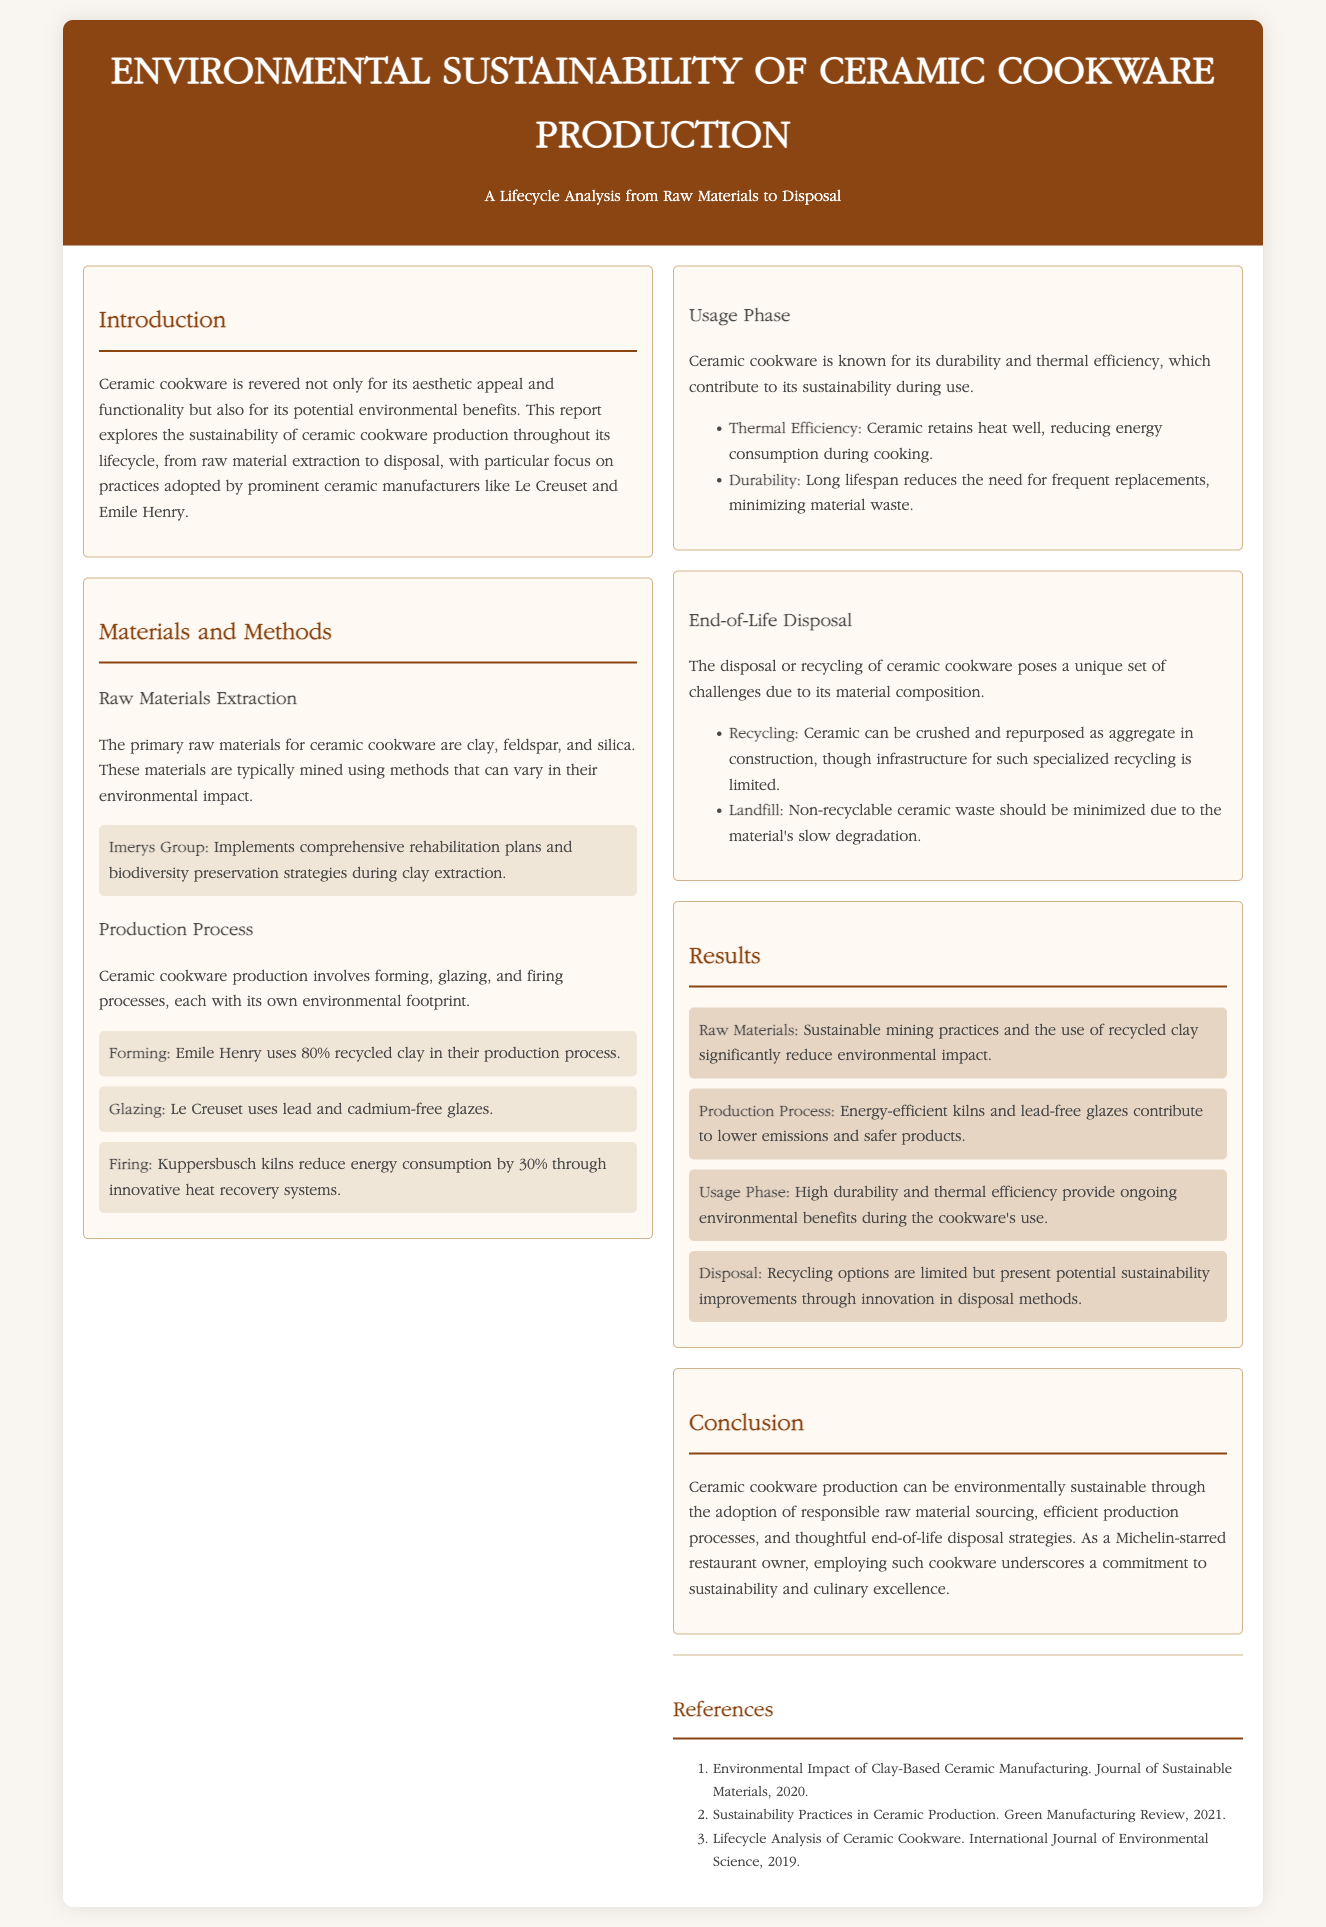what are the primary raw materials for ceramic cookware? The document states that the primary raw materials are clay, feldspar, and silica.
Answer: clay, feldspar, silica which company uses 80% recycled clay in their production process? The text mentions Emile Henry uses 80% recycled clay.
Answer: Emile Henry how much energy consumption is reduced by Kuppersbusch kilns? The document states that Kuppersbusch kilns reduce energy consumption by 30%.
Answer: 30% what is one potential recycling option for ceramic cookware? The report specifies that ceramic can be crushed and repurposed as aggregate in construction.
Answer: crushed and repurposed as aggregate what is a key environmental benefit of ceramic cookware during its usage phase? The document mentions that ceramic retains heat well, reducing energy consumption during cooking.
Answer: reduces energy consumption what is the main conclusion regarding ceramic cookware production? According to the report, ceramic cookware production can be environmentally sustainable through responsible sourcing and efficient processes.
Answer: environmentally sustainable what type of glazes does Le Creuset use? The document indicates that Le Creuset uses lead and cadmium-free glazes.
Answer: lead and cadmium-free which two manufacturers are mentioned regarding their sustainability practices? The text names Le Creuset and Emile Henry in the context of sustainability.
Answer: Le Creuset and Emile Henry what type of report is this document classified as? The document is categorized as a lab report focusing on environmental sustainability.
Answer: lab report 